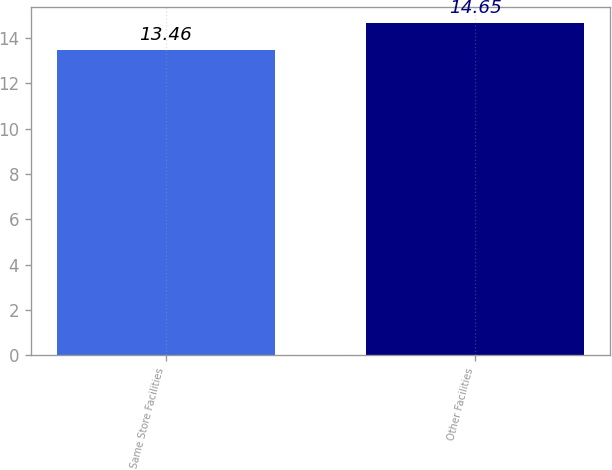Convert chart to OTSL. <chart><loc_0><loc_0><loc_500><loc_500><bar_chart><fcel>Same Store Facilities<fcel>Other Facilities<nl><fcel>13.46<fcel>14.65<nl></chart> 